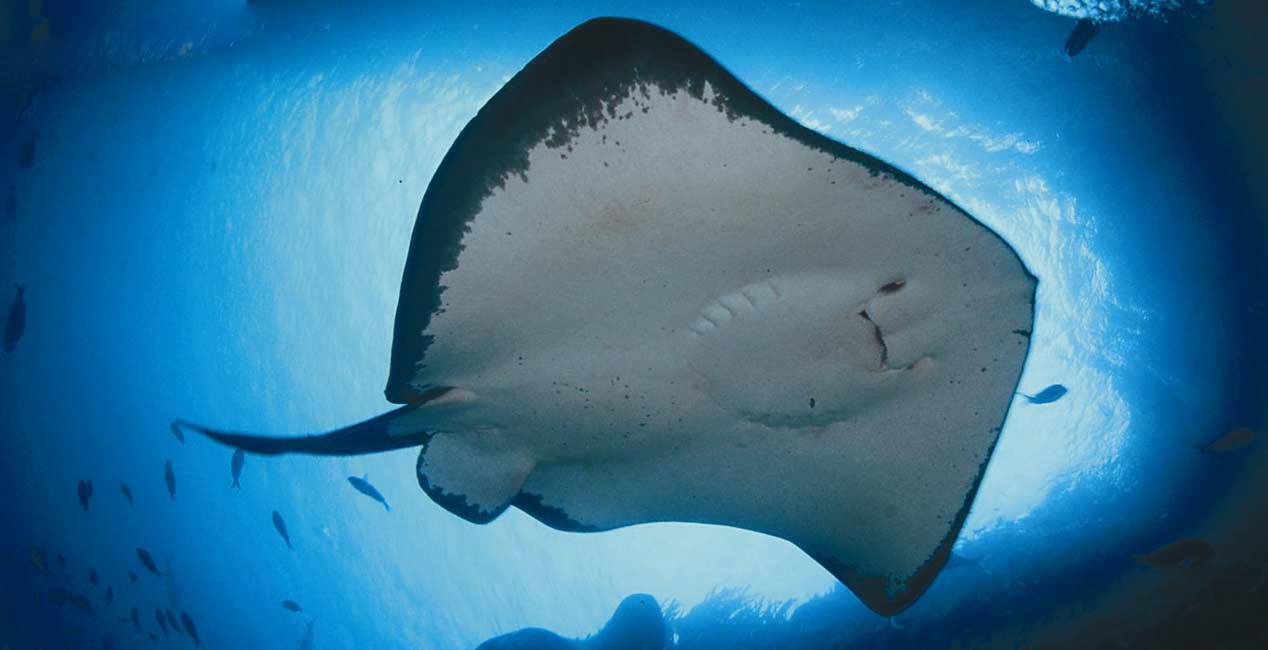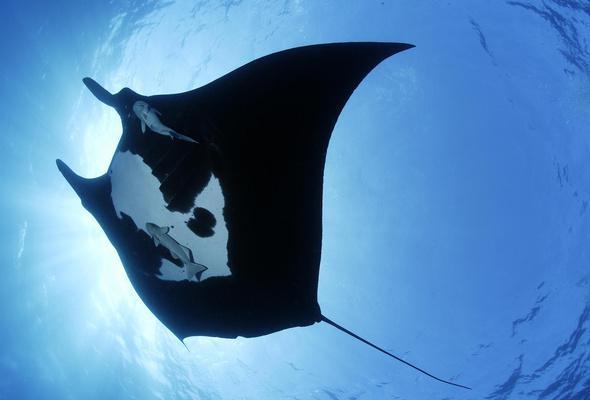The first image is the image on the left, the second image is the image on the right. Evaluate the accuracy of this statement regarding the images: "The animal in the image on the left is just above the seafloor.". Is it true? Answer yes or no. No. 